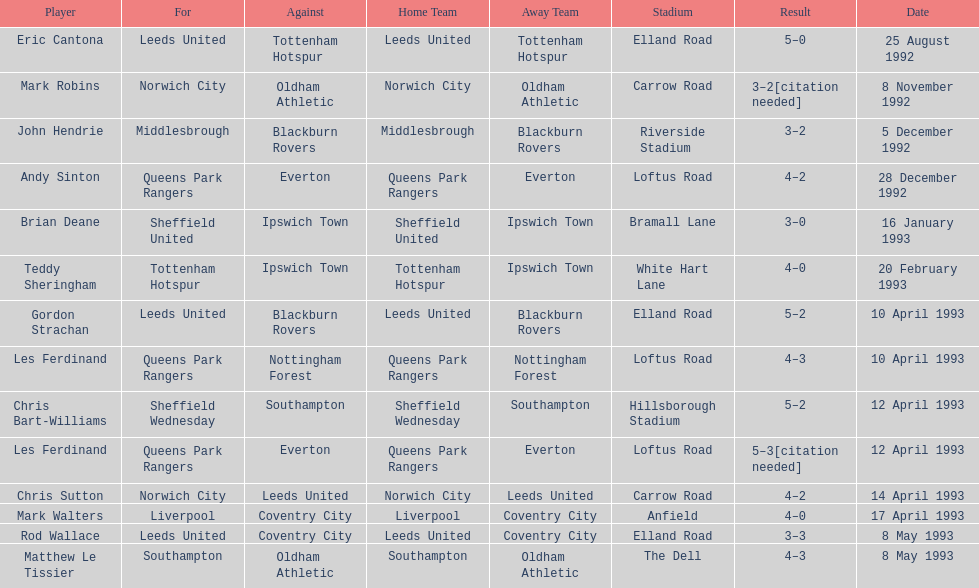In the 1992-1993 premier league, what was the total number of hat tricks scored by all players? 14. 